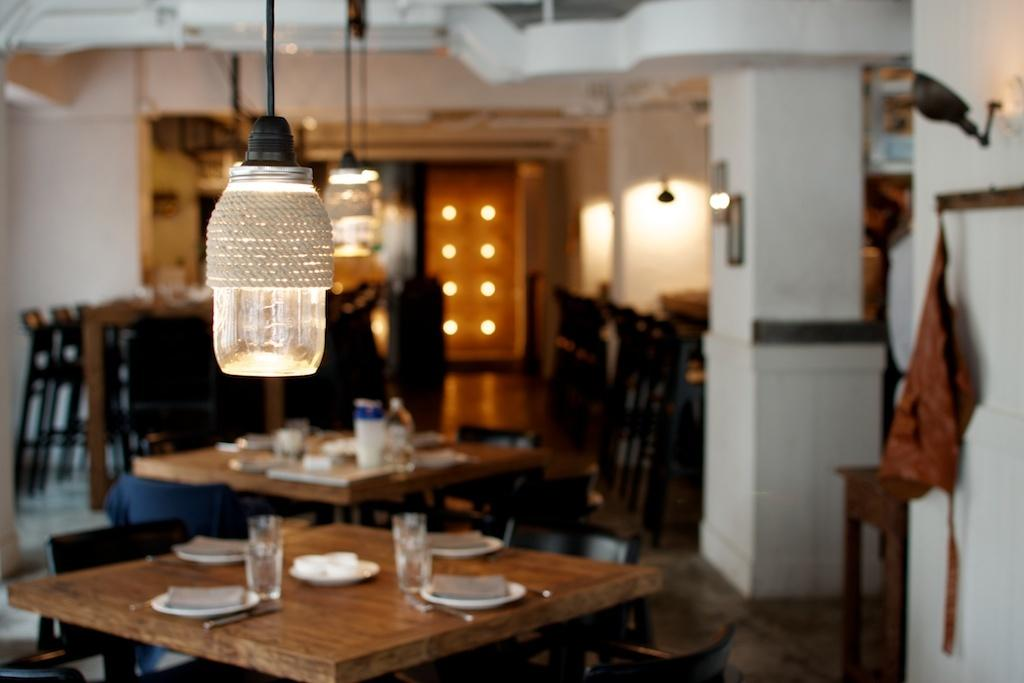What type of furniture is present in the image? There are tables and chairs in the image. What items can be seen on the table? There are glasses, plates, and spoons on the table. What architectural feature is visible in the image? There is a pillar in the image. What surface is the furniture and tableware placed on? There is a floor in the image. What source of illumination is present in the image? There is a light in the image. What type of holiday is being celebrated in the image? There is no indication of a holiday being celebrated in the image. Can you tell me how many elbows are visible in the image? There are no elbows visible in the image, as it primarily features furniture and tableware. 